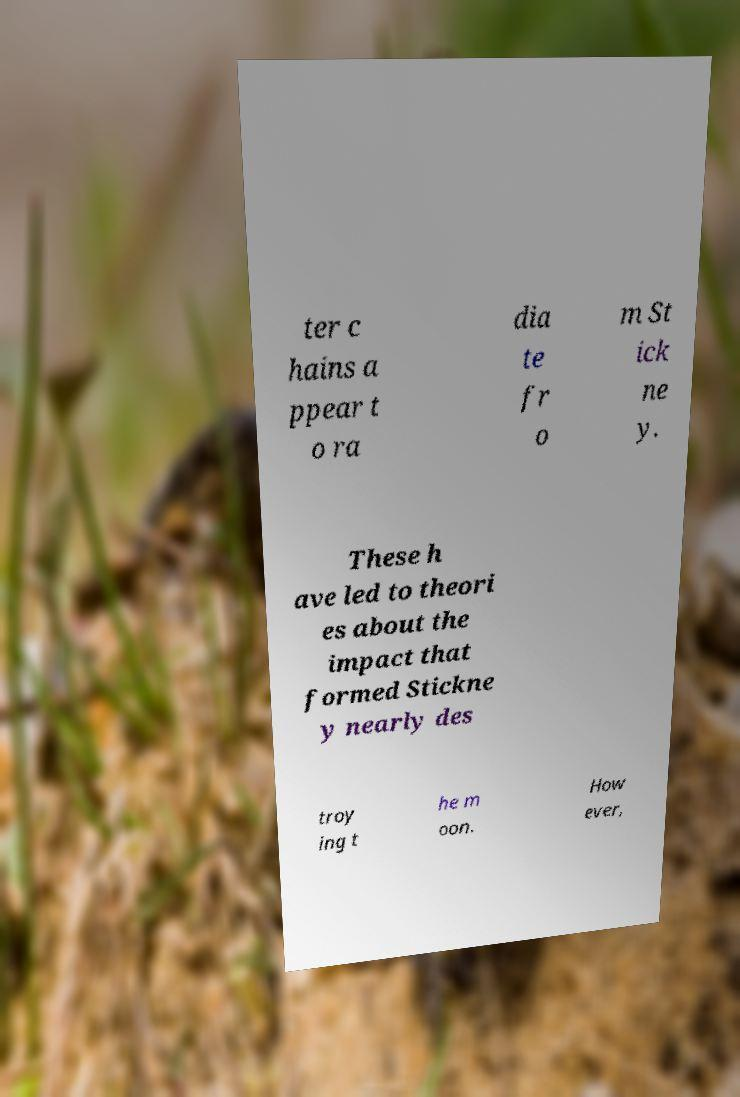Could you extract and type out the text from this image? ter c hains a ppear t o ra dia te fr o m St ick ne y. These h ave led to theori es about the impact that formed Stickne y nearly des troy ing t he m oon. How ever, 